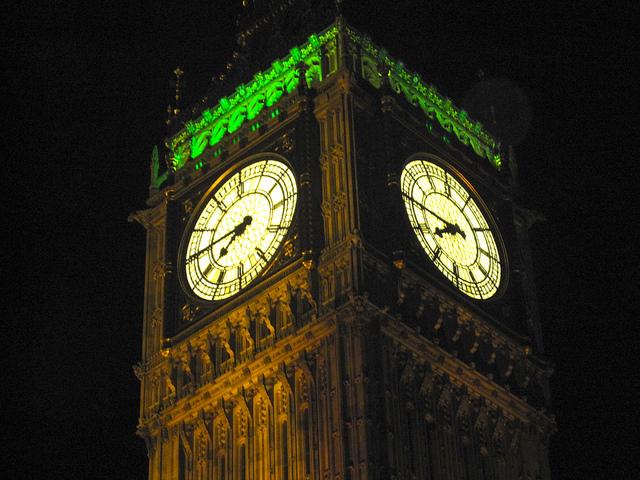What time is on the clock?
Concise answer only. 7:45. How many clocks on the building?
Quick response, please. 2. What time of day is it?
Keep it brief. Night. 